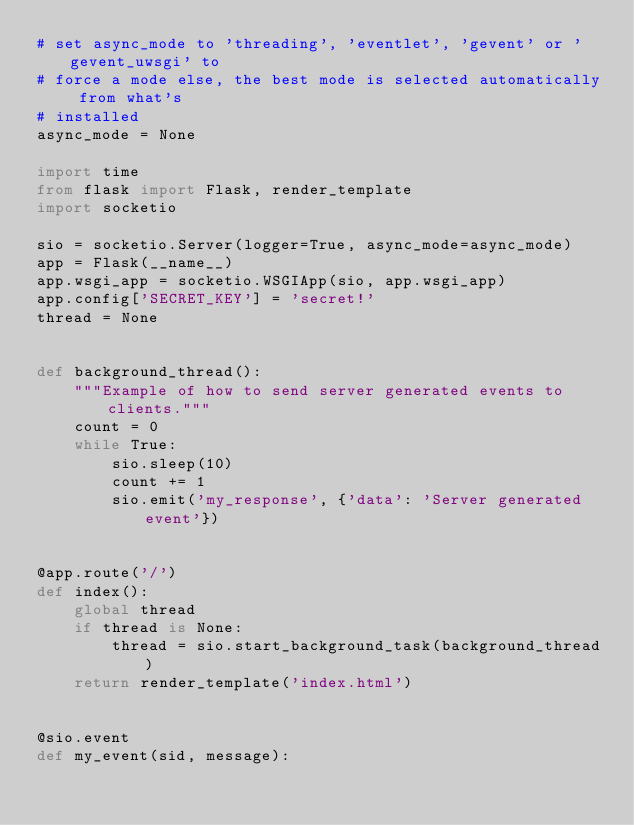Convert code to text. <code><loc_0><loc_0><loc_500><loc_500><_Python_># set async_mode to 'threading', 'eventlet', 'gevent' or 'gevent_uwsgi' to
# force a mode else, the best mode is selected automatically from what's
# installed
async_mode = None

import time
from flask import Flask, render_template
import socketio

sio = socketio.Server(logger=True, async_mode=async_mode)
app = Flask(__name__)
app.wsgi_app = socketio.WSGIApp(sio, app.wsgi_app)
app.config['SECRET_KEY'] = 'secret!'
thread = None


def background_thread():
    """Example of how to send server generated events to clients."""
    count = 0
    while True:
        sio.sleep(10)
        count += 1
        sio.emit('my_response', {'data': 'Server generated event'})


@app.route('/')
def index():
    global thread
    if thread is None:
        thread = sio.start_background_task(background_thread)
    return render_template('index.html')


@sio.event
def my_event(sid, message):</code> 